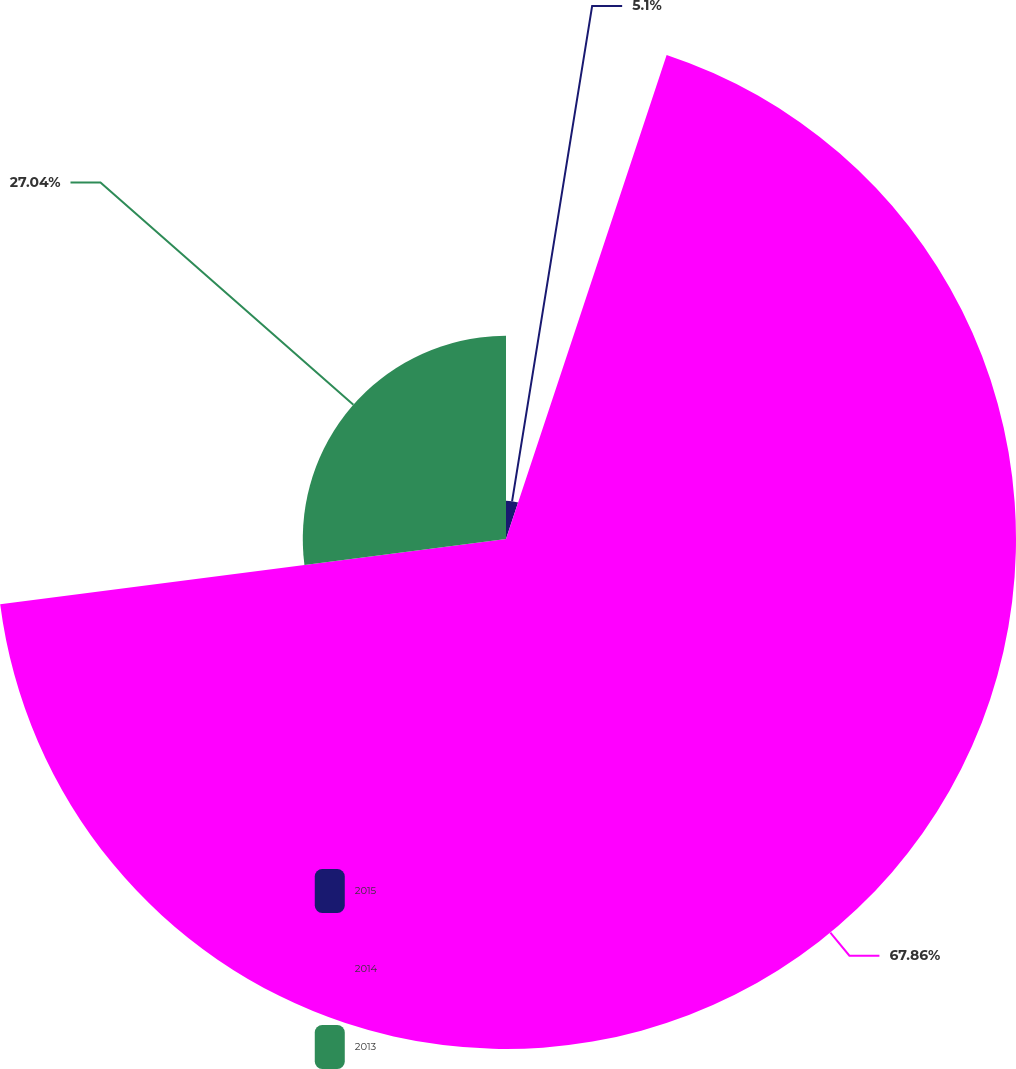Convert chart. <chart><loc_0><loc_0><loc_500><loc_500><pie_chart><fcel>2015<fcel>2014<fcel>2013<nl><fcel>5.1%<fcel>67.86%<fcel>27.04%<nl></chart> 